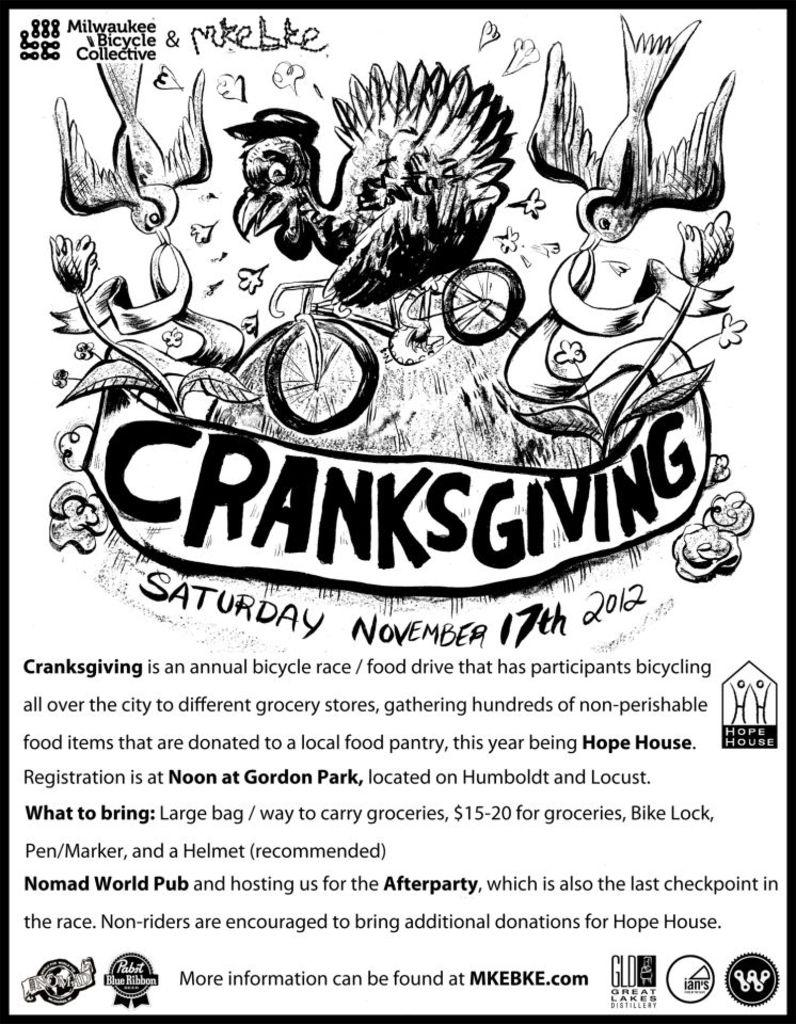<image>
Write a terse but informative summary of the picture. An illustrated page that reads Cranksgiving with several drawings of birds on the top. 